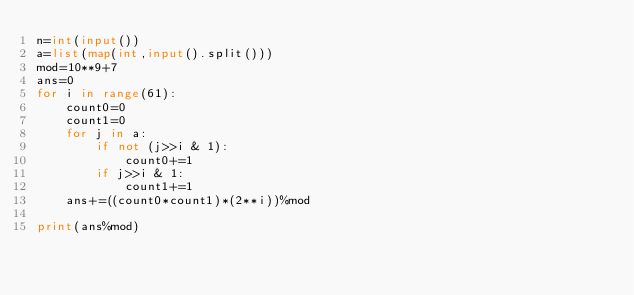<code> <loc_0><loc_0><loc_500><loc_500><_Python_>n=int(input())
a=list(map(int,input().split()))
mod=10**9+7
ans=0
for i in range(61):
    count0=0
    count1=0
    for j in a:
        if not (j>>i & 1):
            count0+=1
        if j>>i & 1:
            count1+=1
    ans+=((count0*count1)*(2**i))%mod
    
print(ans%mod)</code> 